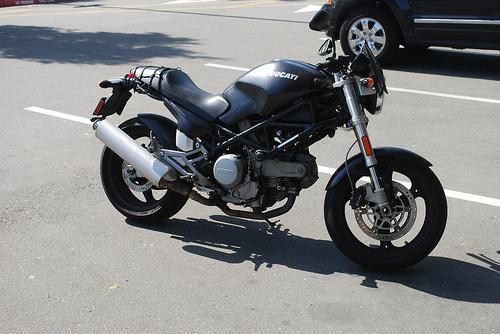How many wheels are on the motorcycle?
Give a very brief answer. 2. How many vehicles are there?
Give a very brief answer. 2. 